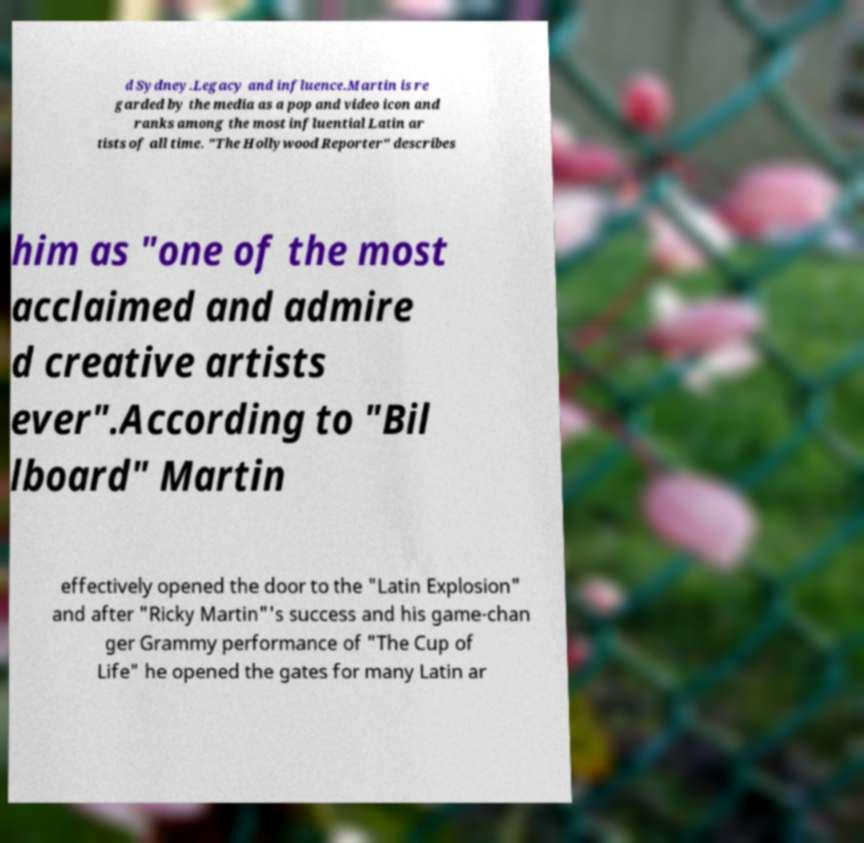Can you read and provide the text displayed in the image?This photo seems to have some interesting text. Can you extract and type it out for me? d Sydney.Legacy and influence.Martin is re garded by the media as a pop and video icon and ranks among the most influential Latin ar tists of all time. "The Hollywood Reporter" describes him as "one of the most acclaimed and admire d creative artists ever".According to "Bil lboard" Martin effectively opened the door to the "Latin Explosion" and after "Ricky Martin"'s success and his game-chan ger Grammy performance of "The Cup of Life" he opened the gates for many Latin ar 